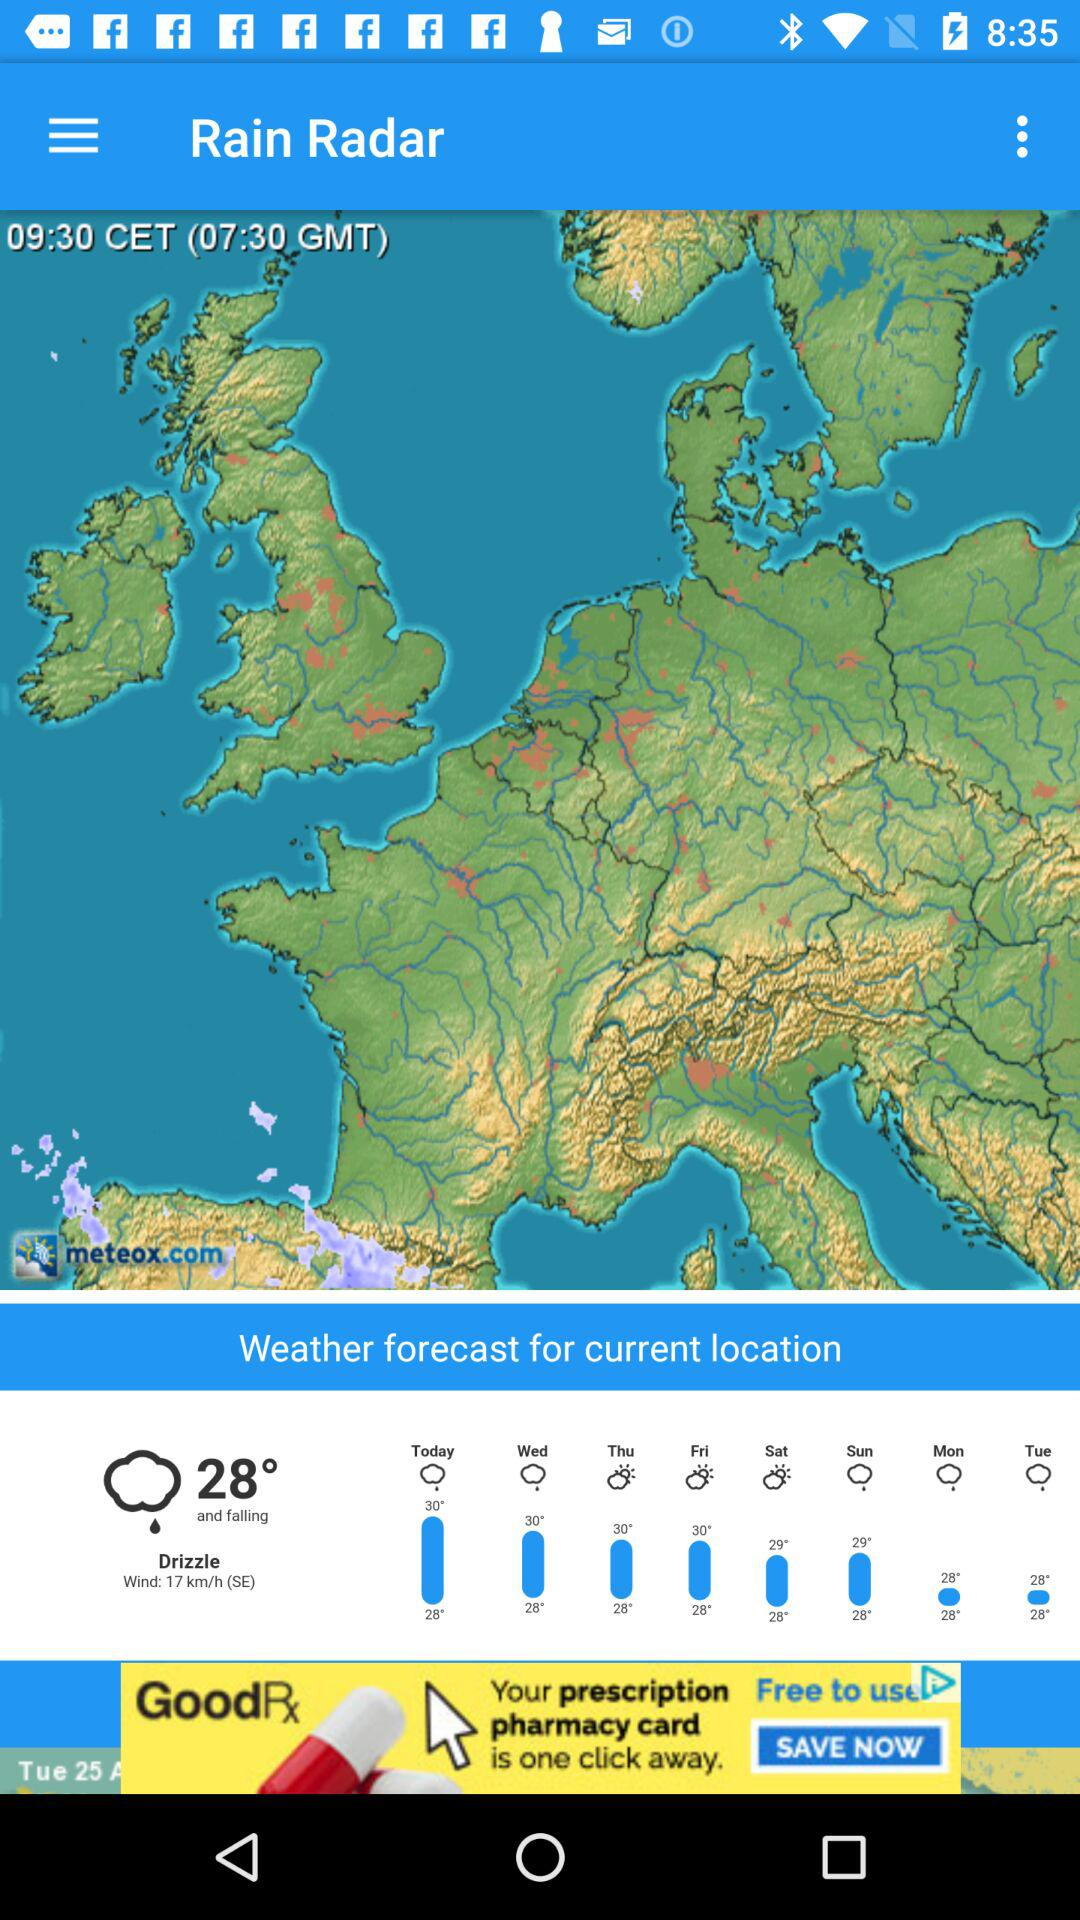What is the name of the application? The name of the application is "Rain Radar". 